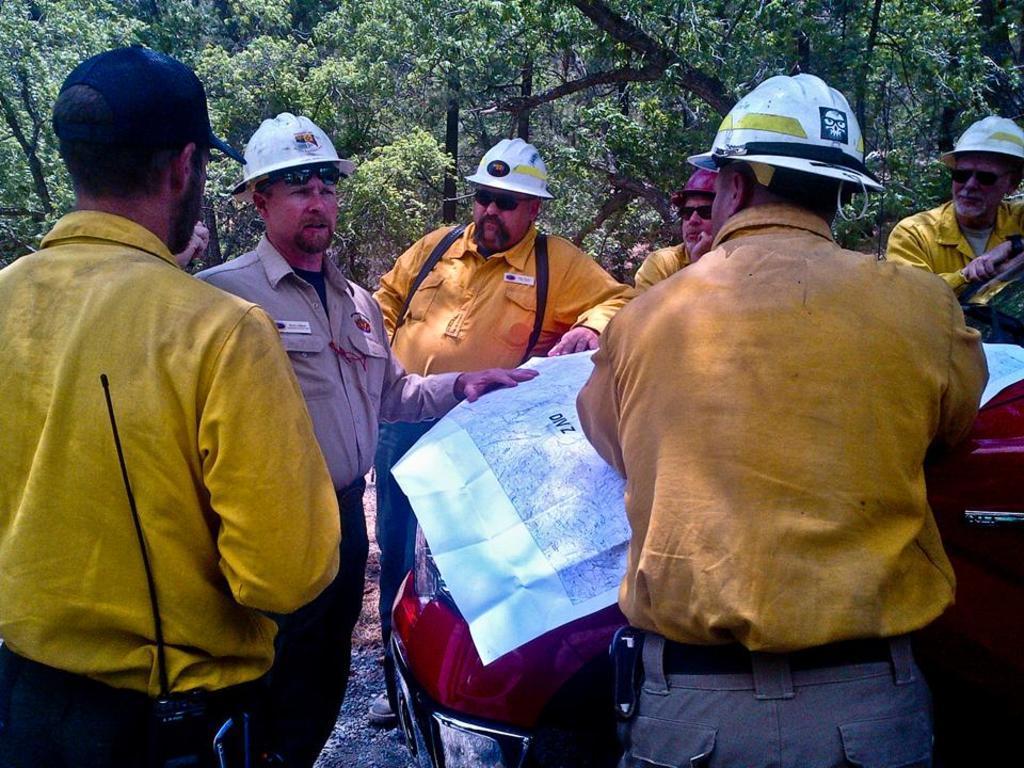In one or two sentences, can you explain what this image depicts? This picture shows few people standing and they wore helmets on their heads and we see a man wore a cap on his head and we see sunglasses on their faces and we see a red car and a man holding map in his hand and we see trees around. 